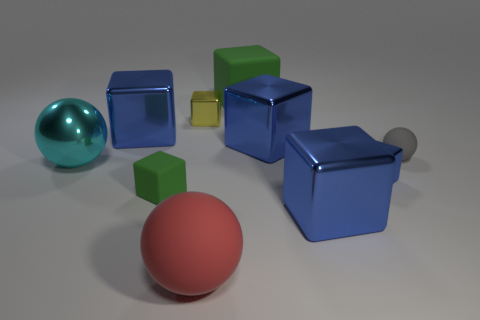How many blue cubes must be subtracted to get 2 blue cubes? 2 Subtract all gray balls. How many blue cubes are left? 4 Subtract all large matte cubes. How many cubes are left? 6 Subtract all yellow cubes. How many cubes are left? 6 Subtract 2 cubes. How many cubes are left? 5 Subtract all red cubes. Subtract all blue cylinders. How many cubes are left? 7 Subtract all blocks. How many objects are left? 3 Add 6 blue objects. How many blue objects are left? 10 Add 4 big cyan shiny things. How many big cyan shiny things exist? 5 Subtract 0 purple cylinders. How many objects are left? 10 